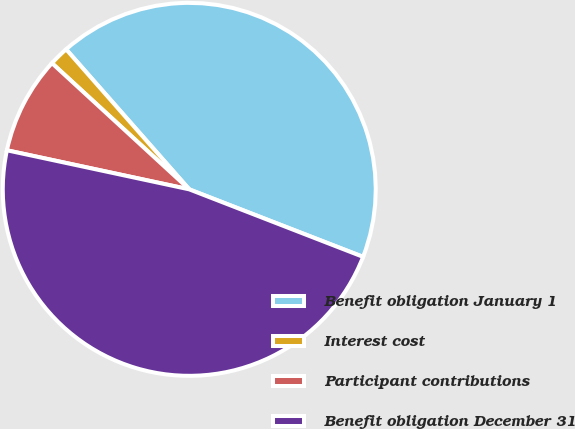Convert chart to OTSL. <chart><loc_0><loc_0><loc_500><loc_500><pie_chart><fcel>Benefit obligation January 1<fcel>Interest cost<fcel>Participant contributions<fcel>Benefit obligation December 31<nl><fcel>42.37%<fcel>1.69%<fcel>8.47%<fcel>47.46%<nl></chart> 